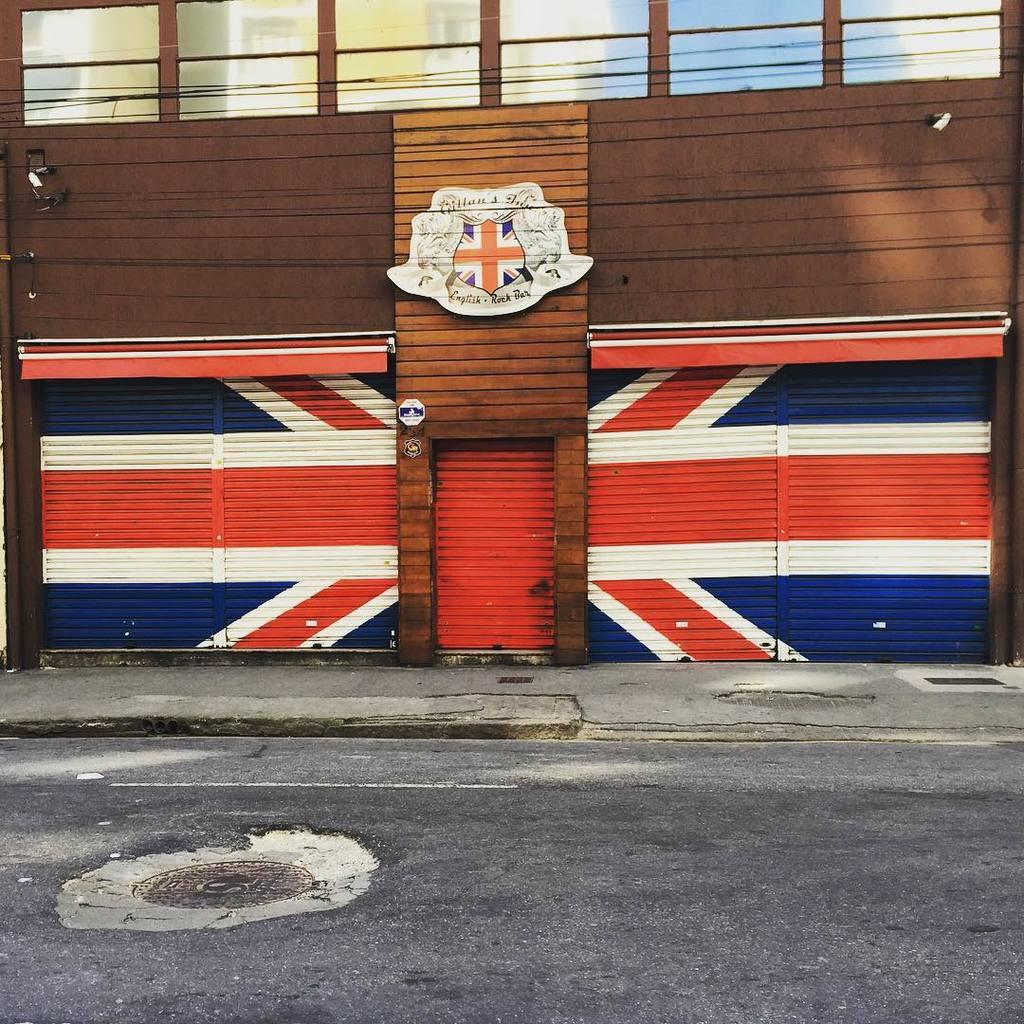What is located at the bottom of the image? There is a road at the bottom of the image. What can be seen in the middle of the image? There is a gate in the middle of the image. What is unique about the gate? The gate has a British country flag. How many cows are grazing near the gate in the image? There are no cows present in the image. What type of business is conducted near the gate in the image? The image does not provide any information about a business being conducted near the gate. 